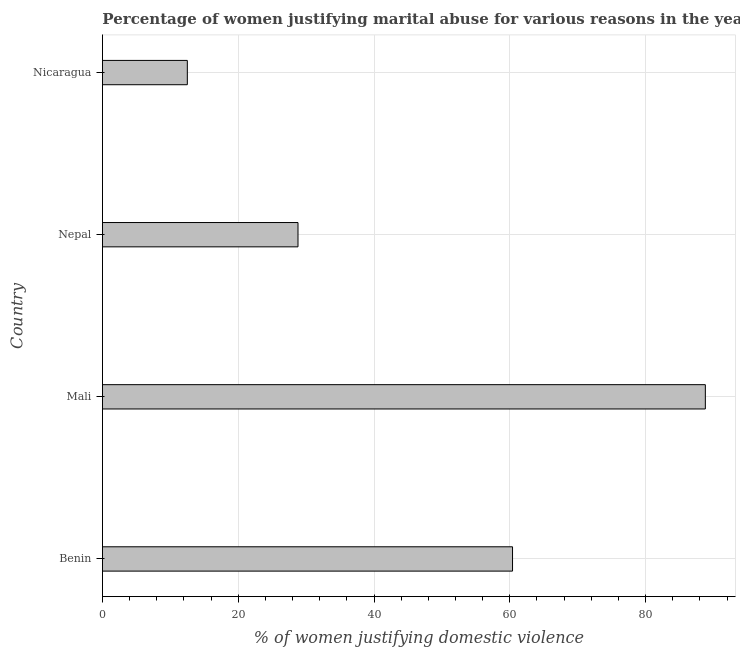Does the graph contain any zero values?
Your answer should be compact. No. What is the title of the graph?
Offer a very short reply. Percentage of women justifying marital abuse for various reasons in the year 2001. What is the label or title of the X-axis?
Make the answer very short. % of women justifying domestic violence. What is the label or title of the Y-axis?
Make the answer very short. Country. What is the percentage of women justifying marital abuse in Nepal?
Give a very brief answer. 28.8. Across all countries, what is the maximum percentage of women justifying marital abuse?
Ensure brevity in your answer.  88.8. Across all countries, what is the minimum percentage of women justifying marital abuse?
Keep it short and to the point. 12.5. In which country was the percentage of women justifying marital abuse maximum?
Ensure brevity in your answer.  Mali. In which country was the percentage of women justifying marital abuse minimum?
Your response must be concise. Nicaragua. What is the sum of the percentage of women justifying marital abuse?
Keep it short and to the point. 190.5. What is the difference between the percentage of women justifying marital abuse in Benin and Nicaragua?
Make the answer very short. 47.9. What is the average percentage of women justifying marital abuse per country?
Give a very brief answer. 47.62. What is the median percentage of women justifying marital abuse?
Offer a terse response. 44.6. What is the ratio of the percentage of women justifying marital abuse in Mali to that in Nepal?
Provide a short and direct response. 3.08. Is the percentage of women justifying marital abuse in Mali less than that in Nepal?
Ensure brevity in your answer.  No. Is the difference between the percentage of women justifying marital abuse in Benin and Nicaragua greater than the difference between any two countries?
Offer a terse response. No. What is the difference between the highest and the second highest percentage of women justifying marital abuse?
Give a very brief answer. 28.4. What is the difference between the highest and the lowest percentage of women justifying marital abuse?
Ensure brevity in your answer.  76.3. In how many countries, is the percentage of women justifying marital abuse greater than the average percentage of women justifying marital abuse taken over all countries?
Keep it short and to the point. 2. Are all the bars in the graph horizontal?
Your answer should be compact. Yes. What is the % of women justifying domestic violence of Benin?
Your response must be concise. 60.4. What is the % of women justifying domestic violence in Mali?
Your answer should be very brief. 88.8. What is the % of women justifying domestic violence in Nepal?
Offer a terse response. 28.8. What is the difference between the % of women justifying domestic violence in Benin and Mali?
Your answer should be very brief. -28.4. What is the difference between the % of women justifying domestic violence in Benin and Nepal?
Make the answer very short. 31.6. What is the difference between the % of women justifying domestic violence in Benin and Nicaragua?
Offer a terse response. 47.9. What is the difference between the % of women justifying domestic violence in Mali and Nepal?
Ensure brevity in your answer.  60. What is the difference between the % of women justifying domestic violence in Mali and Nicaragua?
Ensure brevity in your answer.  76.3. What is the difference between the % of women justifying domestic violence in Nepal and Nicaragua?
Your answer should be compact. 16.3. What is the ratio of the % of women justifying domestic violence in Benin to that in Mali?
Offer a very short reply. 0.68. What is the ratio of the % of women justifying domestic violence in Benin to that in Nepal?
Your answer should be compact. 2.1. What is the ratio of the % of women justifying domestic violence in Benin to that in Nicaragua?
Keep it short and to the point. 4.83. What is the ratio of the % of women justifying domestic violence in Mali to that in Nepal?
Offer a very short reply. 3.08. What is the ratio of the % of women justifying domestic violence in Mali to that in Nicaragua?
Offer a terse response. 7.1. What is the ratio of the % of women justifying domestic violence in Nepal to that in Nicaragua?
Provide a short and direct response. 2.3. 